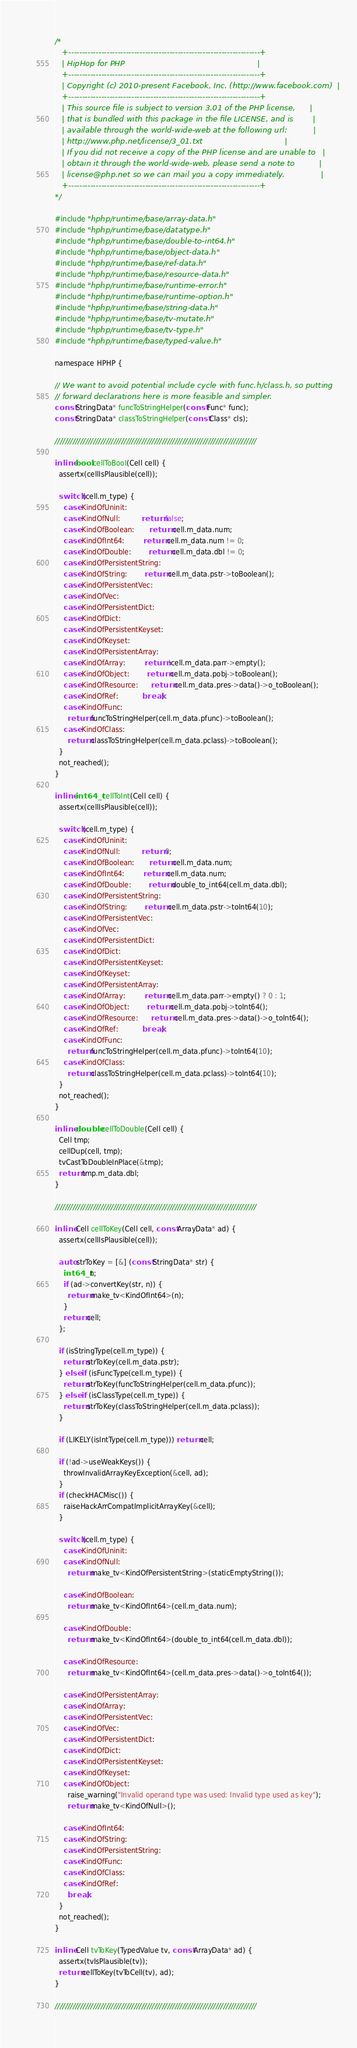<code> <loc_0><loc_0><loc_500><loc_500><_C_>/*
   +----------------------------------------------------------------------+
   | HipHop for PHP                                                       |
   +----------------------------------------------------------------------+
   | Copyright (c) 2010-present Facebook, Inc. (http://www.facebook.com)  |
   +----------------------------------------------------------------------+
   | This source file is subject to version 3.01 of the PHP license,      |
   | that is bundled with this package in the file LICENSE, and is        |
   | available through the world-wide-web at the following url:           |
   | http://www.php.net/license/3_01.txt                                  |
   | If you did not receive a copy of the PHP license and are unable to   |
   | obtain it through the world-wide-web, please send a note to          |
   | license@php.net so we can mail you a copy immediately.               |
   +----------------------------------------------------------------------+
*/

#include "hphp/runtime/base/array-data.h"
#include "hphp/runtime/base/datatype.h"
#include "hphp/runtime/base/double-to-int64.h"
#include "hphp/runtime/base/object-data.h"
#include "hphp/runtime/base/ref-data.h"
#include "hphp/runtime/base/resource-data.h"
#include "hphp/runtime/base/runtime-error.h"
#include "hphp/runtime/base/runtime-option.h"
#include "hphp/runtime/base/string-data.h"
#include "hphp/runtime/base/tv-mutate.h"
#include "hphp/runtime/base/tv-type.h"
#include "hphp/runtime/base/typed-value.h"

namespace HPHP {

// We want to avoid potential include cycle with func.h/class.h, so putting
// forward declarations here is more feasible and simpler.
const StringData* funcToStringHelper(const Func* func);
const StringData* classToStringHelper(const Class* cls);

///////////////////////////////////////////////////////////////////////////////

inline bool cellToBool(Cell cell) {
  assertx(cellIsPlausible(cell));

  switch (cell.m_type) {
    case KindOfUninit:
    case KindOfNull:          return false;
    case KindOfBoolean:       return cell.m_data.num;
    case KindOfInt64:         return cell.m_data.num != 0;
    case KindOfDouble:        return cell.m_data.dbl != 0;
    case KindOfPersistentString:
    case KindOfString:        return cell.m_data.pstr->toBoolean();
    case KindOfPersistentVec:
    case KindOfVec:
    case KindOfPersistentDict:
    case KindOfDict:
    case KindOfPersistentKeyset:
    case KindOfKeyset:
    case KindOfPersistentArray:
    case KindOfArray:         return !cell.m_data.parr->empty();
    case KindOfObject:        return cell.m_data.pobj->toBoolean();
    case KindOfResource:      return cell.m_data.pres->data()->o_toBoolean();
    case KindOfRef:           break;
    case KindOfFunc:
      return funcToStringHelper(cell.m_data.pfunc)->toBoolean();
    case KindOfClass:
      return classToStringHelper(cell.m_data.pclass)->toBoolean();
  }
  not_reached();
}

inline int64_t cellToInt(Cell cell) {
  assertx(cellIsPlausible(cell));

  switch (cell.m_type) {
    case KindOfUninit:
    case KindOfNull:          return 0;
    case KindOfBoolean:       return cell.m_data.num;
    case KindOfInt64:         return cell.m_data.num;
    case KindOfDouble:        return double_to_int64(cell.m_data.dbl);
    case KindOfPersistentString:
    case KindOfString:        return cell.m_data.pstr->toInt64(10);
    case KindOfPersistentVec:
    case KindOfVec:
    case KindOfPersistentDict:
    case KindOfDict:
    case KindOfPersistentKeyset:
    case KindOfKeyset:
    case KindOfPersistentArray:
    case KindOfArray:         return cell.m_data.parr->empty() ? 0 : 1;
    case KindOfObject:        return cell.m_data.pobj->toInt64();
    case KindOfResource:      return cell.m_data.pres->data()->o_toInt64();
    case KindOfRef:           break;
    case KindOfFunc:
      return funcToStringHelper(cell.m_data.pfunc)->toInt64(10);
    case KindOfClass:
      return classToStringHelper(cell.m_data.pclass)->toInt64(10);
  }
  not_reached();
}

inline double cellToDouble(Cell cell) {
  Cell tmp;
  cellDup(cell, tmp);
  tvCastToDoubleInPlace(&tmp);
  return tmp.m_data.dbl;
}

///////////////////////////////////////////////////////////////////////////////

inline Cell cellToKey(Cell cell, const ArrayData* ad) {
  assertx(cellIsPlausible(cell));

  auto strToKey = [&] (const StringData* str) {
    int64_t n;
    if (ad->convertKey(str, n)) {
      return make_tv<KindOfInt64>(n);
    }
    return cell;
  };

  if (isStringType(cell.m_type)) {
    return strToKey(cell.m_data.pstr);
  } else if (isFuncType(cell.m_type)) {
    return strToKey(funcToStringHelper(cell.m_data.pfunc));
  } else if (isClassType(cell.m_type)) {
    return strToKey(classToStringHelper(cell.m_data.pclass));
  }

  if (LIKELY(isIntType(cell.m_type))) return cell;

  if (!ad->useWeakKeys()) {
    throwInvalidArrayKeyException(&cell, ad);
  }
  if (checkHACMisc()) {
    raiseHackArrCompatImplicitArrayKey(&cell);
  }

  switch (cell.m_type) {
    case KindOfUninit:
    case KindOfNull:
      return make_tv<KindOfPersistentString>(staticEmptyString());

    case KindOfBoolean:
      return make_tv<KindOfInt64>(cell.m_data.num);

    case KindOfDouble:
      return make_tv<KindOfInt64>(double_to_int64(cell.m_data.dbl));

    case KindOfResource:
      return make_tv<KindOfInt64>(cell.m_data.pres->data()->o_toInt64());

    case KindOfPersistentArray:
    case KindOfArray:
    case KindOfPersistentVec:
    case KindOfVec:
    case KindOfPersistentDict:
    case KindOfDict:
    case KindOfPersistentKeyset:
    case KindOfKeyset:
    case KindOfObject:
      raise_warning("Invalid operand type was used: Invalid type used as key");
      return make_tv<KindOfNull>();

    case KindOfInt64:
    case KindOfString:
    case KindOfPersistentString:
    case KindOfFunc:
    case KindOfClass:
    case KindOfRef:
      break;
  }
  not_reached();
}

inline Cell tvToKey(TypedValue tv, const ArrayData* ad) {
  assertx(tvIsPlausible(tv));
  return cellToKey(tvToCell(tv), ad);
}

///////////////////////////////////////////////////////////////////////////////
</code> 